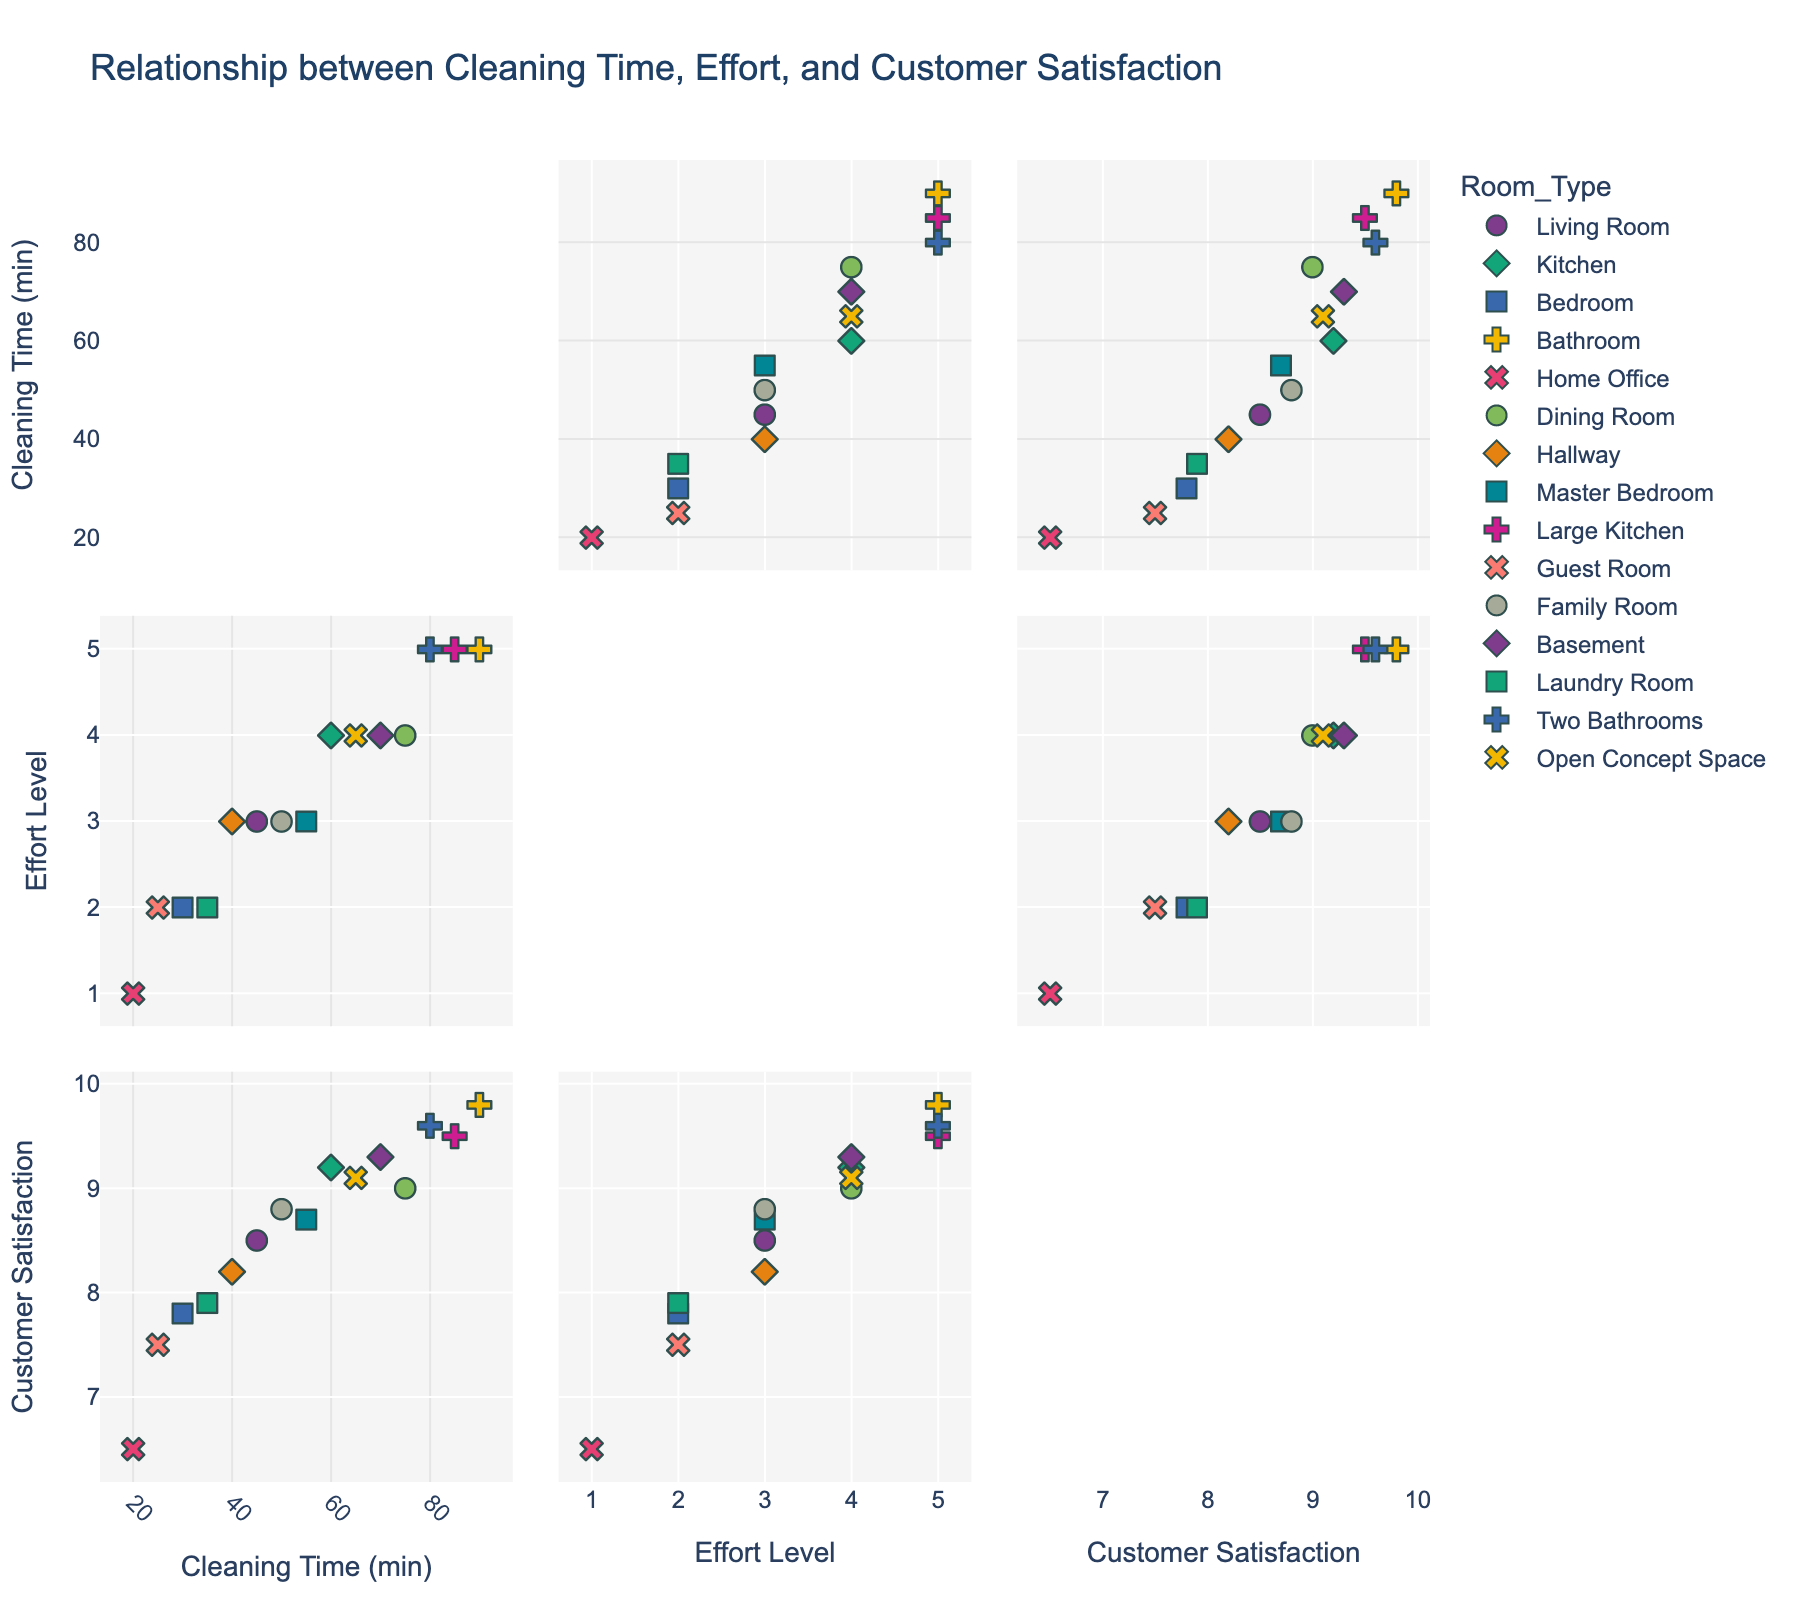How many different room types are represented in the plot? By counting the unique room types (symbols and colors) shown in the scatterplot matrix, we can determine the number of different room types.
Answer: 15 What is the relationship between Cleaning Time and Customer Satisfaction in general? By observing the scatterplot cells that show Cleaning Time versus Customer Satisfaction, you should be able to notice if there is a trend, such as points generally moving upwards (indicating higher satisfaction with more cleaning time) or any other pattern that emerges.
Answer: Positive correlation Which room type seems to require the maximum cleaning time while achieving high customer satisfaction? Look for the room type that appears in the upper right of the scatterplot cell that compares Cleaning Time and Customer Satisfaction. Identify the specific point with the highest values for both variables.
Answer: Bathroom What is the average Effort Level for rooms cleaned in under 30 minutes? Identify the points in the scatterplot for Cleaning Time less than 30 minutes, note their Effort Level values, and calculate the average.
Answer: 1.67 Is there a room type that consistently maintains high customer satisfaction despite varying levels of effort and cleaning time? Examine scatterplot cells showing Customer Satisfaction against both Cleaning Time and Effort Level. Look for room types across these plots that consistently fall in the high satisfaction range regardless of other conditions.
Answer: Bathroom How does Effort Level relate to Customer Satisfaction for rooms that take between 40 and 60 minutes to clean? Find the scatterplot points where Cleaning Time is between 40 and 60 minutes, then observe the Effort Level and corresponding Customer Satisfaction for these points. Determine any pattern or relationship.
Answer: Higher effort, higher satisfaction Do rooms with low Effort Levels generally yield lower customer satisfaction? Analyze scatterplot cells where Effort Level is plotted against Customer Satisfaction. Observe if lower Effort Levels correspond to lower Customer Satisfaction points in general.
Answer: Yes For rooms requiring more than 60 minutes of cleaning time, what is the range of Customer Satisfaction ratings? Identify the scatterplot points where Cleaning Time exceeds 60 minutes, then note the range (minimum and maximum values) of Customer Satisfaction for these points.
Answer: 9.0 - 9.8 Which room types display the most varied results in terms of Customer Satisfaction? Look across all scatterplot cells involving Customer Satisfaction and note which room types (symbols/colors) show a wide range of ratings rather than clustering around a specific value.
Answer: Kitchen, Home Office Is there a significant trend in the relationship between Effort Level and Cleaning Time? By examining the scatterplot cells that plot Effort Level against Cleaning Time, check if there is a linear or non-linear trend visible in the points indicating how these two variables relate.
Answer: Positive correlation 